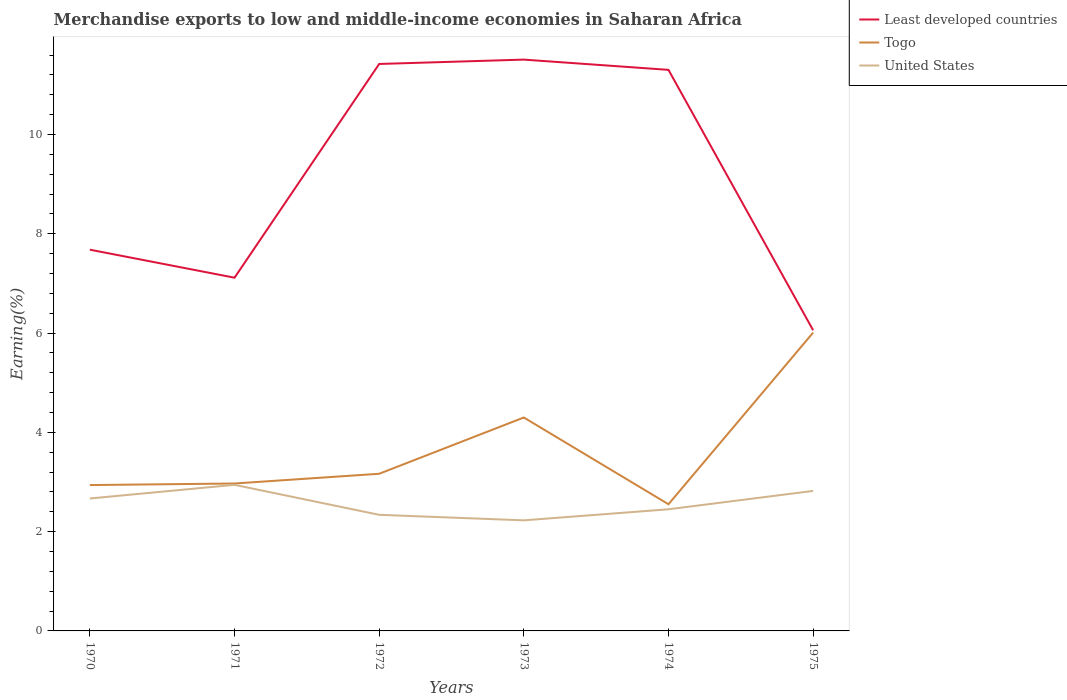How many different coloured lines are there?
Your response must be concise. 3. Is the number of lines equal to the number of legend labels?
Your answer should be compact. Yes. Across all years, what is the maximum percentage of amount earned from merchandise exports in Togo?
Keep it short and to the point. 2.55. In which year was the percentage of amount earned from merchandise exports in Least developed countries maximum?
Provide a succinct answer. 1975. What is the total percentage of amount earned from merchandise exports in Least developed countries in the graph?
Offer a terse response. 0.12. What is the difference between the highest and the second highest percentage of amount earned from merchandise exports in Least developed countries?
Offer a very short reply. 5.45. Is the percentage of amount earned from merchandise exports in Togo strictly greater than the percentage of amount earned from merchandise exports in United States over the years?
Provide a succinct answer. No. How many lines are there?
Offer a very short reply. 3. Does the graph contain any zero values?
Your response must be concise. No. Does the graph contain grids?
Offer a very short reply. No. What is the title of the graph?
Ensure brevity in your answer.  Merchandise exports to low and middle-income economies in Saharan Africa. What is the label or title of the Y-axis?
Ensure brevity in your answer.  Earning(%). What is the Earning(%) of Least developed countries in 1970?
Keep it short and to the point. 7.68. What is the Earning(%) in Togo in 1970?
Offer a very short reply. 2.94. What is the Earning(%) in United States in 1970?
Your answer should be very brief. 2.67. What is the Earning(%) of Least developed countries in 1971?
Give a very brief answer. 7.11. What is the Earning(%) of Togo in 1971?
Your answer should be very brief. 2.97. What is the Earning(%) in United States in 1971?
Your response must be concise. 2.94. What is the Earning(%) of Least developed countries in 1972?
Your response must be concise. 11.42. What is the Earning(%) of Togo in 1972?
Give a very brief answer. 3.17. What is the Earning(%) in United States in 1972?
Give a very brief answer. 2.34. What is the Earning(%) of Least developed countries in 1973?
Offer a very short reply. 11.51. What is the Earning(%) in Togo in 1973?
Provide a succinct answer. 4.3. What is the Earning(%) in United States in 1973?
Provide a succinct answer. 2.23. What is the Earning(%) in Least developed countries in 1974?
Make the answer very short. 11.3. What is the Earning(%) of Togo in 1974?
Your response must be concise. 2.55. What is the Earning(%) of United States in 1974?
Provide a short and direct response. 2.45. What is the Earning(%) of Least developed countries in 1975?
Your answer should be compact. 6.06. What is the Earning(%) of Togo in 1975?
Make the answer very short. 6.01. What is the Earning(%) of United States in 1975?
Give a very brief answer. 2.82. Across all years, what is the maximum Earning(%) in Least developed countries?
Your answer should be very brief. 11.51. Across all years, what is the maximum Earning(%) in Togo?
Make the answer very short. 6.01. Across all years, what is the maximum Earning(%) in United States?
Your answer should be compact. 2.94. Across all years, what is the minimum Earning(%) of Least developed countries?
Give a very brief answer. 6.06. Across all years, what is the minimum Earning(%) of Togo?
Provide a succinct answer. 2.55. Across all years, what is the minimum Earning(%) in United States?
Your response must be concise. 2.23. What is the total Earning(%) in Least developed countries in the graph?
Make the answer very short. 55.08. What is the total Earning(%) in Togo in the graph?
Your answer should be compact. 21.93. What is the total Earning(%) of United States in the graph?
Give a very brief answer. 15.45. What is the difference between the Earning(%) in Least developed countries in 1970 and that in 1971?
Offer a very short reply. 0.56. What is the difference between the Earning(%) of Togo in 1970 and that in 1971?
Keep it short and to the point. -0.03. What is the difference between the Earning(%) in United States in 1970 and that in 1971?
Provide a succinct answer. -0.28. What is the difference between the Earning(%) in Least developed countries in 1970 and that in 1972?
Keep it short and to the point. -3.74. What is the difference between the Earning(%) in Togo in 1970 and that in 1972?
Your answer should be compact. -0.23. What is the difference between the Earning(%) in United States in 1970 and that in 1972?
Offer a terse response. 0.33. What is the difference between the Earning(%) in Least developed countries in 1970 and that in 1973?
Keep it short and to the point. -3.83. What is the difference between the Earning(%) in Togo in 1970 and that in 1973?
Keep it short and to the point. -1.36. What is the difference between the Earning(%) of United States in 1970 and that in 1973?
Offer a terse response. 0.44. What is the difference between the Earning(%) in Least developed countries in 1970 and that in 1974?
Give a very brief answer. -3.62. What is the difference between the Earning(%) in Togo in 1970 and that in 1974?
Ensure brevity in your answer.  0.39. What is the difference between the Earning(%) in United States in 1970 and that in 1974?
Your answer should be compact. 0.22. What is the difference between the Earning(%) in Least developed countries in 1970 and that in 1975?
Offer a terse response. 1.62. What is the difference between the Earning(%) in Togo in 1970 and that in 1975?
Your answer should be compact. -3.07. What is the difference between the Earning(%) of United States in 1970 and that in 1975?
Provide a succinct answer. -0.15. What is the difference between the Earning(%) in Least developed countries in 1971 and that in 1972?
Your answer should be very brief. -4.31. What is the difference between the Earning(%) of Togo in 1971 and that in 1972?
Provide a short and direct response. -0.2. What is the difference between the Earning(%) in United States in 1971 and that in 1972?
Your response must be concise. 0.6. What is the difference between the Earning(%) in Least developed countries in 1971 and that in 1973?
Give a very brief answer. -4.39. What is the difference between the Earning(%) in Togo in 1971 and that in 1973?
Offer a terse response. -1.33. What is the difference between the Earning(%) of United States in 1971 and that in 1973?
Ensure brevity in your answer.  0.72. What is the difference between the Earning(%) in Least developed countries in 1971 and that in 1974?
Provide a short and direct response. -4.19. What is the difference between the Earning(%) in Togo in 1971 and that in 1974?
Provide a succinct answer. 0.42. What is the difference between the Earning(%) of United States in 1971 and that in 1974?
Give a very brief answer. 0.49. What is the difference between the Earning(%) of Least developed countries in 1971 and that in 1975?
Ensure brevity in your answer.  1.06. What is the difference between the Earning(%) of Togo in 1971 and that in 1975?
Offer a terse response. -3.04. What is the difference between the Earning(%) in United States in 1971 and that in 1975?
Make the answer very short. 0.12. What is the difference between the Earning(%) in Least developed countries in 1972 and that in 1973?
Provide a succinct answer. -0.09. What is the difference between the Earning(%) of Togo in 1972 and that in 1973?
Your answer should be very brief. -1.13. What is the difference between the Earning(%) of United States in 1972 and that in 1973?
Provide a short and direct response. 0.11. What is the difference between the Earning(%) in Least developed countries in 1972 and that in 1974?
Offer a very short reply. 0.12. What is the difference between the Earning(%) of Togo in 1972 and that in 1974?
Provide a succinct answer. 0.61. What is the difference between the Earning(%) of United States in 1972 and that in 1974?
Your response must be concise. -0.11. What is the difference between the Earning(%) of Least developed countries in 1972 and that in 1975?
Offer a very short reply. 5.36. What is the difference between the Earning(%) in Togo in 1972 and that in 1975?
Provide a short and direct response. -2.84. What is the difference between the Earning(%) of United States in 1972 and that in 1975?
Offer a very short reply. -0.48. What is the difference between the Earning(%) in Least developed countries in 1973 and that in 1974?
Your answer should be very brief. 0.21. What is the difference between the Earning(%) in Togo in 1973 and that in 1974?
Keep it short and to the point. 1.75. What is the difference between the Earning(%) in United States in 1973 and that in 1974?
Provide a succinct answer. -0.22. What is the difference between the Earning(%) in Least developed countries in 1973 and that in 1975?
Provide a short and direct response. 5.45. What is the difference between the Earning(%) in Togo in 1973 and that in 1975?
Offer a terse response. -1.71. What is the difference between the Earning(%) of United States in 1973 and that in 1975?
Ensure brevity in your answer.  -0.59. What is the difference between the Earning(%) in Least developed countries in 1974 and that in 1975?
Offer a terse response. 5.24. What is the difference between the Earning(%) of Togo in 1974 and that in 1975?
Your answer should be very brief. -3.46. What is the difference between the Earning(%) in United States in 1974 and that in 1975?
Ensure brevity in your answer.  -0.37. What is the difference between the Earning(%) of Least developed countries in 1970 and the Earning(%) of Togo in 1971?
Give a very brief answer. 4.71. What is the difference between the Earning(%) in Least developed countries in 1970 and the Earning(%) in United States in 1971?
Your answer should be compact. 4.74. What is the difference between the Earning(%) of Togo in 1970 and the Earning(%) of United States in 1971?
Keep it short and to the point. -0. What is the difference between the Earning(%) in Least developed countries in 1970 and the Earning(%) in Togo in 1972?
Provide a succinct answer. 4.51. What is the difference between the Earning(%) in Least developed countries in 1970 and the Earning(%) in United States in 1972?
Offer a terse response. 5.34. What is the difference between the Earning(%) in Togo in 1970 and the Earning(%) in United States in 1972?
Your answer should be compact. 0.6. What is the difference between the Earning(%) in Least developed countries in 1970 and the Earning(%) in Togo in 1973?
Ensure brevity in your answer.  3.38. What is the difference between the Earning(%) of Least developed countries in 1970 and the Earning(%) of United States in 1973?
Provide a succinct answer. 5.45. What is the difference between the Earning(%) of Togo in 1970 and the Earning(%) of United States in 1973?
Provide a short and direct response. 0.71. What is the difference between the Earning(%) in Least developed countries in 1970 and the Earning(%) in Togo in 1974?
Keep it short and to the point. 5.13. What is the difference between the Earning(%) of Least developed countries in 1970 and the Earning(%) of United States in 1974?
Provide a succinct answer. 5.23. What is the difference between the Earning(%) in Togo in 1970 and the Earning(%) in United States in 1974?
Ensure brevity in your answer.  0.49. What is the difference between the Earning(%) in Least developed countries in 1970 and the Earning(%) in Togo in 1975?
Keep it short and to the point. 1.67. What is the difference between the Earning(%) of Least developed countries in 1970 and the Earning(%) of United States in 1975?
Your answer should be very brief. 4.86. What is the difference between the Earning(%) in Togo in 1970 and the Earning(%) in United States in 1975?
Keep it short and to the point. 0.12. What is the difference between the Earning(%) in Least developed countries in 1971 and the Earning(%) in Togo in 1972?
Keep it short and to the point. 3.95. What is the difference between the Earning(%) of Least developed countries in 1971 and the Earning(%) of United States in 1972?
Offer a terse response. 4.78. What is the difference between the Earning(%) of Togo in 1971 and the Earning(%) of United States in 1972?
Offer a terse response. 0.63. What is the difference between the Earning(%) of Least developed countries in 1971 and the Earning(%) of Togo in 1973?
Provide a short and direct response. 2.82. What is the difference between the Earning(%) in Least developed countries in 1971 and the Earning(%) in United States in 1973?
Ensure brevity in your answer.  4.89. What is the difference between the Earning(%) in Togo in 1971 and the Earning(%) in United States in 1973?
Your answer should be very brief. 0.74. What is the difference between the Earning(%) in Least developed countries in 1971 and the Earning(%) in Togo in 1974?
Offer a terse response. 4.56. What is the difference between the Earning(%) of Least developed countries in 1971 and the Earning(%) of United States in 1974?
Provide a succinct answer. 4.66. What is the difference between the Earning(%) in Togo in 1971 and the Earning(%) in United States in 1974?
Offer a terse response. 0.52. What is the difference between the Earning(%) in Least developed countries in 1971 and the Earning(%) in Togo in 1975?
Your response must be concise. 1.11. What is the difference between the Earning(%) in Least developed countries in 1971 and the Earning(%) in United States in 1975?
Give a very brief answer. 4.29. What is the difference between the Earning(%) in Togo in 1971 and the Earning(%) in United States in 1975?
Your answer should be very brief. 0.15. What is the difference between the Earning(%) in Least developed countries in 1972 and the Earning(%) in Togo in 1973?
Make the answer very short. 7.12. What is the difference between the Earning(%) of Least developed countries in 1972 and the Earning(%) of United States in 1973?
Offer a very short reply. 9.19. What is the difference between the Earning(%) of Togo in 1972 and the Earning(%) of United States in 1973?
Offer a very short reply. 0.94. What is the difference between the Earning(%) of Least developed countries in 1972 and the Earning(%) of Togo in 1974?
Offer a terse response. 8.87. What is the difference between the Earning(%) in Least developed countries in 1972 and the Earning(%) in United States in 1974?
Make the answer very short. 8.97. What is the difference between the Earning(%) in Togo in 1972 and the Earning(%) in United States in 1974?
Ensure brevity in your answer.  0.72. What is the difference between the Earning(%) of Least developed countries in 1972 and the Earning(%) of Togo in 1975?
Provide a succinct answer. 5.41. What is the difference between the Earning(%) in Least developed countries in 1972 and the Earning(%) in United States in 1975?
Provide a succinct answer. 8.6. What is the difference between the Earning(%) of Togo in 1972 and the Earning(%) of United States in 1975?
Your answer should be very brief. 0.35. What is the difference between the Earning(%) in Least developed countries in 1973 and the Earning(%) in Togo in 1974?
Offer a very short reply. 8.96. What is the difference between the Earning(%) in Least developed countries in 1973 and the Earning(%) in United States in 1974?
Your answer should be compact. 9.06. What is the difference between the Earning(%) of Togo in 1973 and the Earning(%) of United States in 1974?
Provide a short and direct response. 1.85. What is the difference between the Earning(%) of Least developed countries in 1973 and the Earning(%) of Togo in 1975?
Your answer should be very brief. 5.5. What is the difference between the Earning(%) in Least developed countries in 1973 and the Earning(%) in United States in 1975?
Give a very brief answer. 8.69. What is the difference between the Earning(%) in Togo in 1973 and the Earning(%) in United States in 1975?
Provide a succinct answer. 1.48. What is the difference between the Earning(%) of Least developed countries in 1974 and the Earning(%) of Togo in 1975?
Offer a terse response. 5.29. What is the difference between the Earning(%) in Least developed countries in 1974 and the Earning(%) in United States in 1975?
Provide a short and direct response. 8.48. What is the difference between the Earning(%) in Togo in 1974 and the Earning(%) in United States in 1975?
Offer a terse response. -0.27. What is the average Earning(%) of Least developed countries per year?
Offer a terse response. 9.18. What is the average Earning(%) in Togo per year?
Give a very brief answer. 3.66. What is the average Earning(%) of United States per year?
Ensure brevity in your answer.  2.57. In the year 1970, what is the difference between the Earning(%) in Least developed countries and Earning(%) in Togo?
Provide a succinct answer. 4.74. In the year 1970, what is the difference between the Earning(%) of Least developed countries and Earning(%) of United States?
Make the answer very short. 5.01. In the year 1970, what is the difference between the Earning(%) of Togo and Earning(%) of United States?
Your answer should be very brief. 0.27. In the year 1971, what is the difference between the Earning(%) of Least developed countries and Earning(%) of Togo?
Keep it short and to the point. 4.15. In the year 1971, what is the difference between the Earning(%) of Least developed countries and Earning(%) of United States?
Make the answer very short. 4.17. In the year 1971, what is the difference between the Earning(%) in Togo and Earning(%) in United States?
Offer a terse response. 0.03. In the year 1972, what is the difference between the Earning(%) in Least developed countries and Earning(%) in Togo?
Offer a very short reply. 8.25. In the year 1972, what is the difference between the Earning(%) of Least developed countries and Earning(%) of United States?
Provide a succinct answer. 9.08. In the year 1972, what is the difference between the Earning(%) of Togo and Earning(%) of United States?
Offer a terse response. 0.83. In the year 1973, what is the difference between the Earning(%) in Least developed countries and Earning(%) in Togo?
Your answer should be compact. 7.21. In the year 1973, what is the difference between the Earning(%) of Least developed countries and Earning(%) of United States?
Keep it short and to the point. 9.28. In the year 1973, what is the difference between the Earning(%) of Togo and Earning(%) of United States?
Your answer should be compact. 2.07. In the year 1974, what is the difference between the Earning(%) of Least developed countries and Earning(%) of Togo?
Your response must be concise. 8.75. In the year 1974, what is the difference between the Earning(%) in Least developed countries and Earning(%) in United States?
Your answer should be very brief. 8.85. In the year 1974, what is the difference between the Earning(%) in Togo and Earning(%) in United States?
Your answer should be compact. 0.1. In the year 1975, what is the difference between the Earning(%) of Least developed countries and Earning(%) of Togo?
Offer a very short reply. 0.05. In the year 1975, what is the difference between the Earning(%) in Least developed countries and Earning(%) in United States?
Offer a terse response. 3.24. In the year 1975, what is the difference between the Earning(%) of Togo and Earning(%) of United States?
Give a very brief answer. 3.19. What is the ratio of the Earning(%) in Least developed countries in 1970 to that in 1971?
Your response must be concise. 1.08. What is the ratio of the Earning(%) in Togo in 1970 to that in 1971?
Provide a succinct answer. 0.99. What is the ratio of the Earning(%) of United States in 1970 to that in 1971?
Provide a succinct answer. 0.91. What is the ratio of the Earning(%) in Least developed countries in 1970 to that in 1972?
Ensure brevity in your answer.  0.67. What is the ratio of the Earning(%) in Togo in 1970 to that in 1972?
Ensure brevity in your answer.  0.93. What is the ratio of the Earning(%) in United States in 1970 to that in 1972?
Offer a terse response. 1.14. What is the ratio of the Earning(%) of Least developed countries in 1970 to that in 1973?
Offer a very short reply. 0.67. What is the ratio of the Earning(%) of Togo in 1970 to that in 1973?
Give a very brief answer. 0.68. What is the ratio of the Earning(%) in United States in 1970 to that in 1973?
Offer a very short reply. 1.2. What is the ratio of the Earning(%) of Least developed countries in 1970 to that in 1974?
Ensure brevity in your answer.  0.68. What is the ratio of the Earning(%) of Togo in 1970 to that in 1974?
Ensure brevity in your answer.  1.15. What is the ratio of the Earning(%) of United States in 1970 to that in 1974?
Your answer should be very brief. 1.09. What is the ratio of the Earning(%) of Least developed countries in 1970 to that in 1975?
Offer a terse response. 1.27. What is the ratio of the Earning(%) of Togo in 1970 to that in 1975?
Give a very brief answer. 0.49. What is the ratio of the Earning(%) of United States in 1970 to that in 1975?
Give a very brief answer. 0.95. What is the ratio of the Earning(%) of Least developed countries in 1971 to that in 1972?
Make the answer very short. 0.62. What is the ratio of the Earning(%) in Togo in 1971 to that in 1972?
Provide a succinct answer. 0.94. What is the ratio of the Earning(%) of United States in 1971 to that in 1972?
Keep it short and to the point. 1.26. What is the ratio of the Earning(%) of Least developed countries in 1971 to that in 1973?
Your answer should be compact. 0.62. What is the ratio of the Earning(%) of Togo in 1971 to that in 1973?
Provide a succinct answer. 0.69. What is the ratio of the Earning(%) of United States in 1971 to that in 1973?
Make the answer very short. 1.32. What is the ratio of the Earning(%) in Least developed countries in 1971 to that in 1974?
Offer a terse response. 0.63. What is the ratio of the Earning(%) in Togo in 1971 to that in 1974?
Your answer should be very brief. 1.16. What is the ratio of the Earning(%) in United States in 1971 to that in 1974?
Offer a very short reply. 1.2. What is the ratio of the Earning(%) in Least developed countries in 1971 to that in 1975?
Your answer should be very brief. 1.17. What is the ratio of the Earning(%) in Togo in 1971 to that in 1975?
Offer a terse response. 0.49. What is the ratio of the Earning(%) in United States in 1971 to that in 1975?
Keep it short and to the point. 1.04. What is the ratio of the Earning(%) of Least developed countries in 1972 to that in 1973?
Ensure brevity in your answer.  0.99. What is the ratio of the Earning(%) of Togo in 1972 to that in 1973?
Offer a terse response. 0.74. What is the ratio of the Earning(%) in Least developed countries in 1972 to that in 1974?
Keep it short and to the point. 1.01. What is the ratio of the Earning(%) of Togo in 1972 to that in 1974?
Provide a succinct answer. 1.24. What is the ratio of the Earning(%) in United States in 1972 to that in 1974?
Offer a very short reply. 0.95. What is the ratio of the Earning(%) of Least developed countries in 1972 to that in 1975?
Offer a terse response. 1.89. What is the ratio of the Earning(%) in Togo in 1972 to that in 1975?
Offer a very short reply. 0.53. What is the ratio of the Earning(%) of United States in 1972 to that in 1975?
Give a very brief answer. 0.83. What is the ratio of the Earning(%) in Least developed countries in 1973 to that in 1974?
Your response must be concise. 1.02. What is the ratio of the Earning(%) in Togo in 1973 to that in 1974?
Your response must be concise. 1.68. What is the ratio of the Earning(%) in United States in 1973 to that in 1974?
Keep it short and to the point. 0.91. What is the ratio of the Earning(%) in Least developed countries in 1973 to that in 1975?
Give a very brief answer. 1.9. What is the ratio of the Earning(%) of Togo in 1973 to that in 1975?
Offer a terse response. 0.72. What is the ratio of the Earning(%) of United States in 1973 to that in 1975?
Your answer should be compact. 0.79. What is the ratio of the Earning(%) in Least developed countries in 1974 to that in 1975?
Give a very brief answer. 1.87. What is the ratio of the Earning(%) of Togo in 1974 to that in 1975?
Keep it short and to the point. 0.42. What is the ratio of the Earning(%) of United States in 1974 to that in 1975?
Offer a terse response. 0.87. What is the difference between the highest and the second highest Earning(%) in Least developed countries?
Provide a succinct answer. 0.09. What is the difference between the highest and the second highest Earning(%) in Togo?
Ensure brevity in your answer.  1.71. What is the difference between the highest and the second highest Earning(%) of United States?
Provide a short and direct response. 0.12. What is the difference between the highest and the lowest Earning(%) of Least developed countries?
Make the answer very short. 5.45. What is the difference between the highest and the lowest Earning(%) of Togo?
Provide a short and direct response. 3.46. What is the difference between the highest and the lowest Earning(%) in United States?
Your answer should be compact. 0.72. 